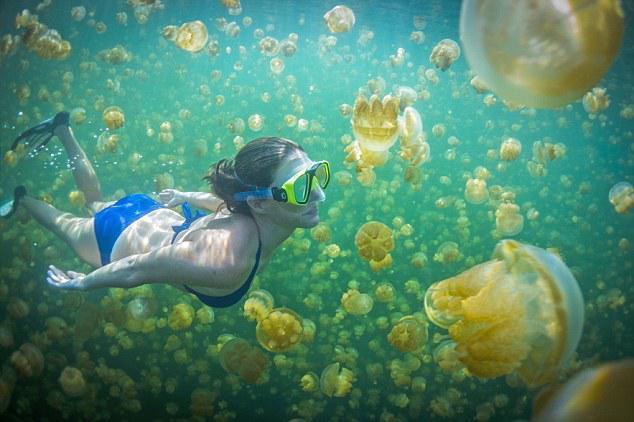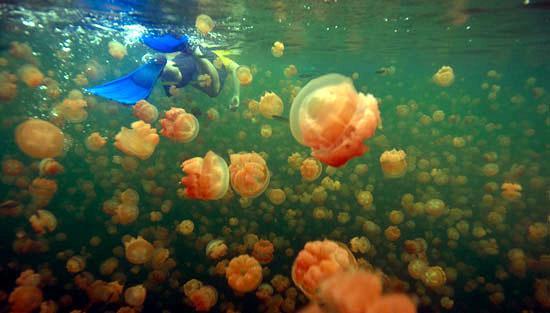The first image is the image on the left, the second image is the image on the right. For the images shown, is this caption "A female in flippers is swimming in the image on the left." true? Answer yes or no. Yes. The first image is the image on the left, the second image is the image on the right. Given the left and right images, does the statement "A diver in a black wetsuit is near at least one pale beige mushroom-look jellyfish." hold true? Answer yes or no. No. 